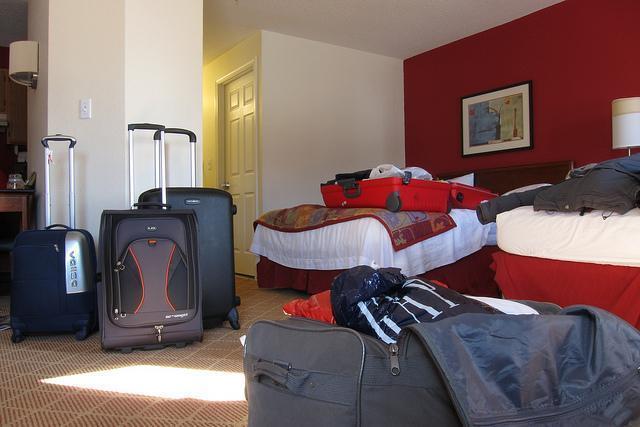How many beds are in the picture?
Give a very brief answer. 2. How many suitcases are in the picture?
Give a very brief answer. 2. 